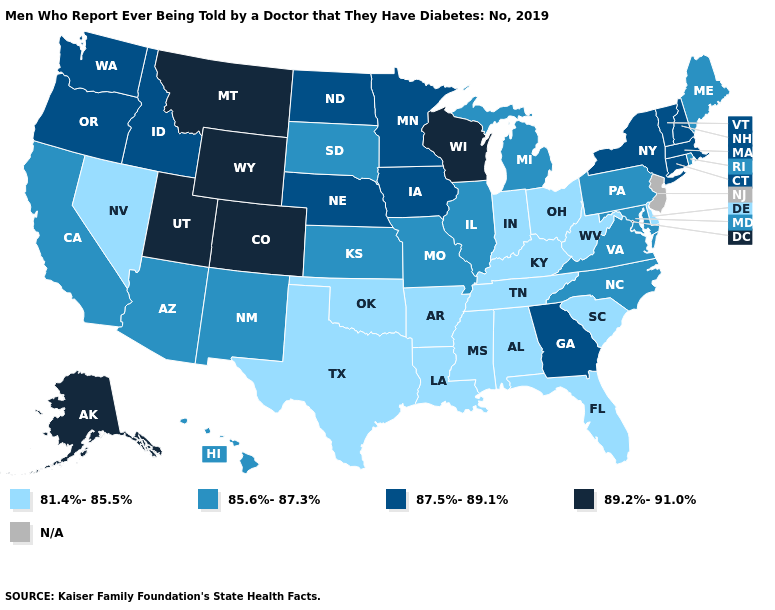Which states hav the highest value in the MidWest?
Concise answer only. Wisconsin. What is the highest value in the South ?
Write a very short answer. 87.5%-89.1%. How many symbols are there in the legend?
Quick response, please. 5. Does the first symbol in the legend represent the smallest category?
Answer briefly. Yes. What is the value of New Mexico?
Quick response, please. 85.6%-87.3%. Which states hav the highest value in the South?
Quick response, please. Georgia. Is the legend a continuous bar?
Give a very brief answer. No. What is the value of South Carolina?
Quick response, please. 81.4%-85.5%. Among the states that border Indiana , does Michigan have the highest value?
Quick response, please. Yes. Name the states that have a value in the range 81.4%-85.5%?
Short answer required. Alabama, Arkansas, Delaware, Florida, Indiana, Kentucky, Louisiana, Mississippi, Nevada, Ohio, Oklahoma, South Carolina, Tennessee, Texas, West Virginia. What is the highest value in states that border Utah?
Concise answer only. 89.2%-91.0%. Name the states that have a value in the range 81.4%-85.5%?
Quick response, please. Alabama, Arkansas, Delaware, Florida, Indiana, Kentucky, Louisiana, Mississippi, Nevada, Ohio, Oklahoma, South Carolina, Tennessee, Texas, West Virginia. Does Rhode Island have the lowest value in the Northeast?
Answer briefly. Yes. What is the lowest value in the USA?
Short answer required. 81.4%-85.5%. 